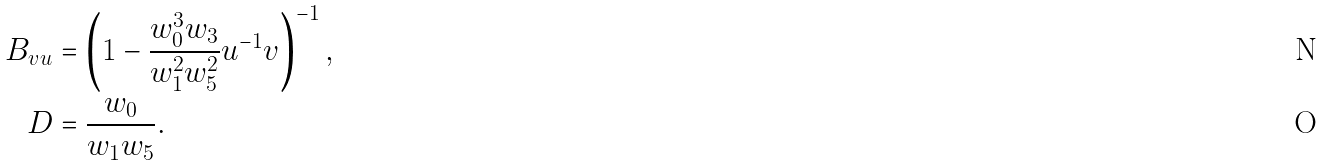<formula> <loc_0><loc_0><loc_500><loc_500>B _ { v u } & = \left ( 1 - \frac { w _ { 0 } ^ { 3 } w _ { 3 } } { w _ { 1 } ^ { 2 } w _ { 5 } ^ { 2 } } u ^ { - 1 } v \right ) ^ { - 1 } , \\ D & = \frac { w _ { 0 } } { w _ { 1 } w _ { 5 } } .</formula> 